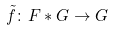<formula> <loc_0><loc_0><loc_500><loc_500>\tilde { f } \colon F * G \rightarrow G</formula> 